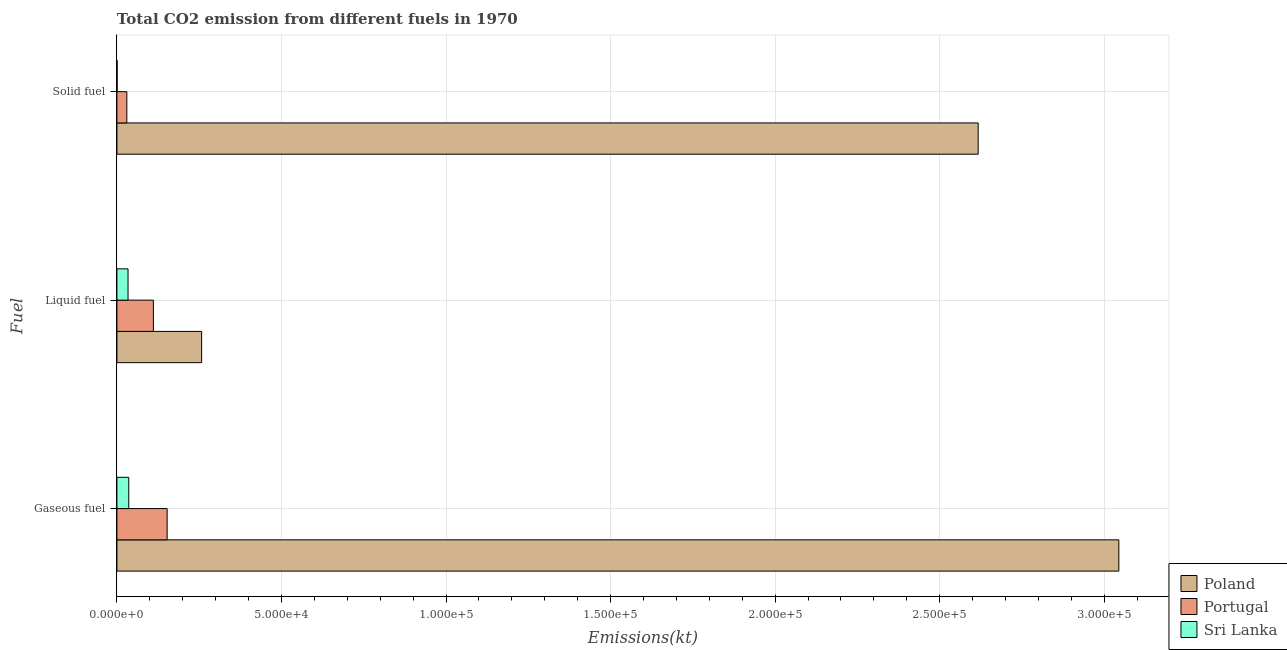How many different coloured bars are there?
Provide a short and direct response. 3. How many groups of bars are there?
Your answer should be compact. 3. Are the number of bars per tick equal to the number of legend labels?
Give a very brief answer. Yes. Are the number of bars on each tick of the Y-axis equal?
Your response must be concise. Yes. What is the label of the 3rd group of bars from the top?
Provide a succinct answer. Gaseous fuel. What is the amount of co2 emissions from solid fuel in Portugal?
Offer a terse response. 3010.61. Across all countries, what is the maximum amount of co2 emissions from solid fuel?
Offer a terse response. 2.62e+05. Across all countries, what is the minimum amount of co2 emissions from gaseous fuel?
Your answer should be compact. 3597.33. In which country was the amount of co2 emissions from gaseous fuel minimum?
Offer a terse response. Sri Lanka. What is the total amount of co2 emissions from liquid fuel in the graph?
Give a very brief answer. 4.02e+04. What is the difference between the amount of co2 emissions from gaseous fuel in Portugal and that in Poland?
Your response must be concise. -2.89e+05. What is the difference between the amount of co2 emissions from liquid fuel in Poland and the amount of co2 emissions from gaseous fuel in Sri Lanka?
Provide a short and direct response. 2.21e+04. What is the average amount of co2 emissions from liquid fuel per country?
Your response must be concise. 1.34e+04. What is the difference between the amount of co2 emissions from gaseous fuel and amount of co2 emissions from solid fuel in Poland?
Keep it short and to the point. 4.27e+04. In how many countries, is the amount of co2 emissions from liquid fuel greater than 20000 kt?
Provide a short and direct response. 1. What is the ratio of the amount of co2 emissions from solid fuel in Sri Lanka to that in Portugal?
Provide a short and direct response. 0.02. Is the difference between the amount of co2 emissions from gaseous fuel in Poland and Portugal greater than the difference between the amount of co2 emissions from liquid fuel in Poland and Portugal?
Your answer should be very brief. Yes. What is the difference between the highest and the second highest amount of co2 emissions from gaseous fuel?
Offer a very short reply. 2.89e+05. What is the difference between the highest and the lowest amount of co2 emissions from solid fuel?
Make the answer very short. 2.62e+05. What does the 2nd bar from the top in Liquid fuel represents?
Offer a terse response. Portugal. What does the 1st bar from the bottom in Gaseous fuel represents?
Provide a short and direct response. Poland. How many countries are there in the graph?
Your answer should be compact. 3. Does the graph contain grids?
Your response must be concise. Yes. Where does the legend appear in the graph?
Provide a short and direct response. Bottom right. How are the legend labels stacked?
Provide a succinct answer. Vertical. What is the title of the graph?
Give a very brief answer. Total CO2 emission from different fuels in 1970. Does "Swaziland" appear as one of the legend labels in the graph?
Make the answer very short. No. What is the label or title of the X-axis?
Provide a short and direct response. Emissions(kt). What is the label or title of the Y-axis?
Offer a terse response. Fuel. What is the Emissions(kt) in Poland in Gaseous fuel?
Your response must be concise. 3.04e+05. What is the Emissions(kt) in Portugal in Gaseous fuel?
Your answer should be very brief. 1.53e+04. What is the Emissions(kt) in Sri Lanka in Gaseous fuel?
Provide a succinct answer. 3597.33. What is the Emissions(kt) of Poland in Liquid fuel?
Provide a short and direct response. 2.57e+04. What is the Emissions(kt) of Portugal in Liquid fuel?
Your answer should be very brief. 1.11e+04. What is the Emissions(kt) in Sri Lanka in Liquid fuel?
Give a very brief answer. 3377.31. What is the Emissions(kt) of Poland in Solid fuel?
Keep it short and to the point. 2.62e+05. What is the Emissions(kt) in Portugal in Solid fuel?
Keep it short and to the point. 3010.61. What is the Emissions(kt) of Sri Lanka in Solid fuel?
Provide a short and direct response. 58.67. Across all Fuel, what is the maximum Emissions(kt) in Poland?
Offer a very short reply. 3.04e+05. Across all Fuel, what is the maximum Emissions(kt) in Portugal?
Offer a terse response. 1.53e+04. Across all Fuel, what is the maximum Emissions(kt) in Sri Lanka?
Your answer should be compact. 3597.33. Across all Fuel, what is the minimum Emissions(kt) in Poland?
Provide a succinct answer. 2.57e+04. Across all Fuel, what is the minimum Emissions(kt) of Portugal?
Your answer should be compact. 3010.61. Across all Fuel, what is the minimum Emissions(kt) in Sri Lanka?
Keep it short and to the point. 58.67. What is the total Emissions(kt) of Poland in the graph?
Offer a terse response. 5.92e+05. What is the total Emissions(kt) in Portugal in the graph?
Your answer should be very brief. 2.94e+04. What is the total Emissions(kt) in Sri Lanka in the graph?
Your answer should be compact. 7033.31. What is the difference between the Emissions(kt) of Poland in Gaseous fuel and that in Liquid fuel?
Offer a terse response. 2.79e+05. What is the difference between the Emissions(kt) of Portugal in Gaseous fuel and that in Liquid fuel?
Give a very brief answer. 4176.71. What is the difference between the Emissions(kt) in Sri Lanka in Gaseous fuel and that in Liquid fuel?
Your answer should be very brief. 220.02. What is the difference between the Emissions(kt) in Poland in Gaseous fuel and that in Solid fuel?
Your response must be concise. 4.27e+04. What is the difference between the Emissions(kt) in Portugal in Gaseous fuel and that in Solid fuel?
Ensure brevity in your answer.  1.22e+04. What is the difference between the Emissions(kt) of Sri Lanka in Gaseous fuel and that in Solid fuel?
Your response must be concise. 3538.66. What is the difference between the Emissions(kt) of Poland in Liquid fuel and that in Solid fuel?
Provide a succinct answer. -2.36e+05. What is the difference between the Emissions(kt) of Portugal in Liquid fuel and that in Solid fuel?
Your answer should be very brief. 8071.07. What is the difference between the Emissions(kt) of Sri Lanka in Liquid fuel and that in Solid fuel?
Offer a terse response. 3318.64. What is the difference between the Emissions(kt) of Poland in Gaseous fuel and the Emissions(kt) of Portugal in Liquid fuel?
Keep it short and to the point. 2.93e+05. What is the difference between the Emissions(kt) in Poland in Gaseous fuel and the Emissions(kt) in Sri Lanka in Liquid fuel?
Your answer should be very brief. 3.01e+05. What is the difference between the Emissions(kt) in Portugal in Gaseous fuel and the Emissions(kt) in Sri Lanka in Liquid fuel?
Offer a terse response. 1.19e+04. What is the difference between the Emissions(kt) of Poland in Gaseous fuel and the Emissions(kt) of Portugal in Solid fuel?
Offer a very short reply. 3.01e+05. What is the difference between the Emissions(kt) in Poland in Gaseous fuel and the Emissions(kt) in Sri Lanka in Solid fuel?
Make the answer very short. 3.04e+05. What is the difference between the Emissions(kt) in Portugal in Gaseous fuel and the Emissions(kt) in Sri Lanka in Solid fuel?
Keep it short and to the point. 1.52e+04. What is the difference between the Emissions(kt) in Poland in Liquid fuel and the Emissions(kt) in Portugal in Solid fuel?
Ensure brevity in your answer.  2.27e+04. What is the difference between the Emissions(kt) of Poland in Liquid fuel and the Emissions(kt) of Sri Lanka in Solid fuel?
Your answer should be very brief. 2.57e+04. What is the difference between the Emissions(kt) in Portugal in Liquid fuel and the Emissions(kt) in Sri Lanka in Solid fuel?
Your response must be concise. 1.10e+04. What is the average Emissions(kt) in Poland per Fuel?
Your answer should be very brief. 1.97e+05. What is the average Emissions(kt) of Portugal per Fuel?
Your answer should be very brief. 9783.56. What is the average Emissions(kt) of Sri Lanka per Fuel?
Your answer should be compact. 2344.44. What is the difference between the Emissions(kt) in Poland and Emissions(kt) in Portugal in Gaseous fuel?
Offer a very short reply. 2.89e+05. What is the difference between the Emissions(kt) of Poland and Emissions(kt) of Sri Lanka in Gaseous fuel?
Offer a very short reply. 3.01e+05. What is the difference between the Emissions(kt) of Portugal and Emissions(kt) of Sri Lanka in Gaseous fuel?
Provide a succinct answer. 1.17e+04. What is the difference between the Emissions(kt) in Poland and Emissions(kt) in Portugal in Liquid fuel?
Provide a succinct answer. 1.47e+04. What is the difference between the Emissions(kt) in Poland and Emissions(kt) in Sri Lanka in Liquid fuel?
Your response must be concise. 2.24e+04. What is the difference between the Emissions(kt) of Portugal and Emissions(kt) of Sri Lanka in Liquid fuel?
Ensure brevity in your answer.  7704.37. What is the difference between the Emissions(kt) of Poland and Emissions(kt) of Portugal in Solid fuel?
Give a very brief answer. 2.59e+05. What is the difference between the Emissions(kt) of Poland and Emissions(kt) of Sri Lanka in Solid fuel?
Provide a short and direct response. 2.62e+05. What is the difference between the Emissions(kt) of Portugal and Emissions(kt) of Sri Lanka in Solid fuel?
Your answer should be very brief. 2951.93. What is the ratio of the Emissions(kt) of Poland in Gaseous fuel to that in Liquid fuel?
Provide a short and direct response. 11.83. What is the ratio of the Emissions(kt) in Portugal in Gaseous fuel to that in Liquid fuel?
Offer a very short reply. 1.38. What is the ratio of the Emissions(kt) in Sri Lanka in Gaseous fuel to that in Liquid fuel?
Give a very brief answer. 1.07. What is the ratio of the Emissions(kt) in Poland in Gaseous fuel to that in Solid fuel?
Provide a succinct answer. 1.16. What is the ratio of the Emissions(kt) in Portugal in Gaseous fuel to that in Solid fuel?
Ensure brevity in your answer.  5.07. What is the ratio of the Emissions(kt) in Sri Lanka in Gaseous fuel to that in Solid fuel?
Provide a succinct answer. 61.31. What is the ratio of the Emissions(kt) of Poland in Liquid fuel to that in Solid fuel?
Your response must be concise. 0.1. What is the ratio of the Emissions(kt) in Portugal in Liquid fuel to that in Solid fuel?
Provide a succinct answer. 3.68. What is the ratio of the Emissions(kt) of Sri Lanka in Liquid fuel to that in Solid fuel?
Provide a short and direct response. 57.56. What is the difference between the highest and the second highest Emissions(kt) of Poland?
Ensure brevity in your answer.  4.27e+04. What is the difference between the highest and the second highest Emissions(kt) in Portugal?
Provide a succinct answer. 4176.71. What is the difference between the highest and the second highest Emissions(kt) of Sri Lanka?
Keep it short and to the point. 220.02. What is the difference between the highest and the lowest Emissions(kt) in Poland?
Your answer should be very brief. 2.79e+05. What is the difference between the highest and the lowest Emissions(kt) of Portugal?
Offer a terse response. 1.22e+04. What is the difference between the highest and the lowest Emissions(kt) of Sri Lanka?
Provide a succinct answer. 3538.66. 